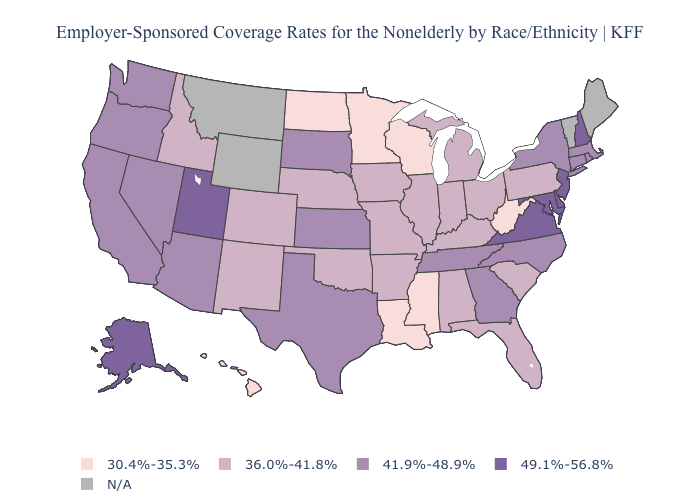Among the states that border Ohio , does West Virginia have the highest value?
Concise answer only. No. Name the states that have a value in the range 30.4%-35.3%?
Short answer required. Hawaii, Louisiana, Minnesota, Mississippi, North Dakota, West Virginia, Wisconsin. Which states hav the highest value in the South?
Give a very brief answer. Delaware, Maryland, Virginia. Name the states that have a value in the range 36.0%-41.8%?
Concise answer only. Alabama, Arkansas, Colorado, Florida, Idaho, Illinois, Indiana, Iowa, Kentucky, Michigan, Missouri, Nebraska, New Mexico, Ohio, Oklahoma, Pennsylvania, South Carolina. What is the value of Oklahoma?
Answer briefly. 36.0%-41.8%. What is the value of Idaho?
Short answer required. 36.0%-41.8%. What is the value of Arizona?
Quick response, please. 41.9%-48.9%. What is the highest value in the USA?
Write a very short answer. 49.1%-56.8%. What is the lowest value in states that border North Carolina?
Be succinct. 36.0%-41.8%. What is the highest value in states that border Oregon?
Short answer required. 41.9%-48.9%. What is the value of Mississippi?
Quick response, please. 30.4%-35.3%. Does Wisconsin have the lowest value in the MidWest?
Be succinct. Yes. What is the lowest value in the USA?
Give a very brief answer. 30.4%-35.3%. 